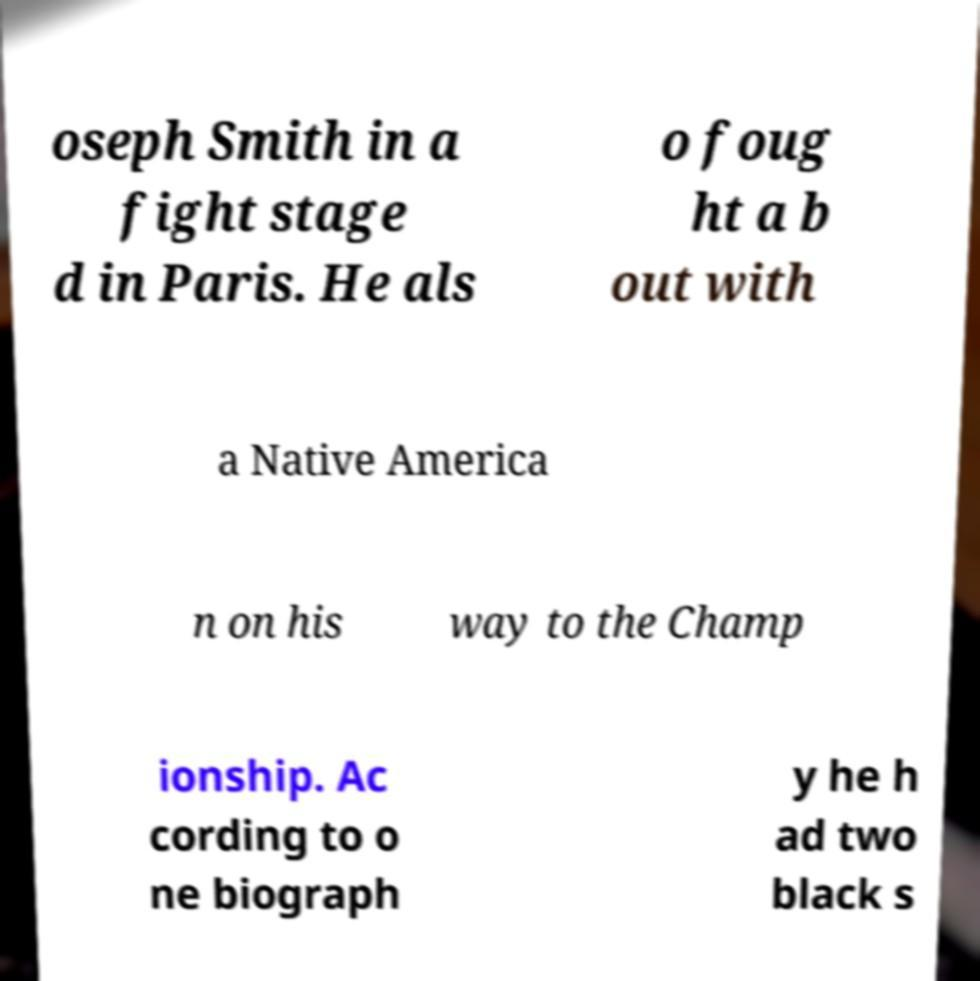Can you accurately transcribe the text from the provided image for me? oseph Smith in a fight stage d in Paris. He als o foug ht a b out with a Native America n on his way to the Champ ionship. Ac cording to o ne biograph y he h ad two black s 